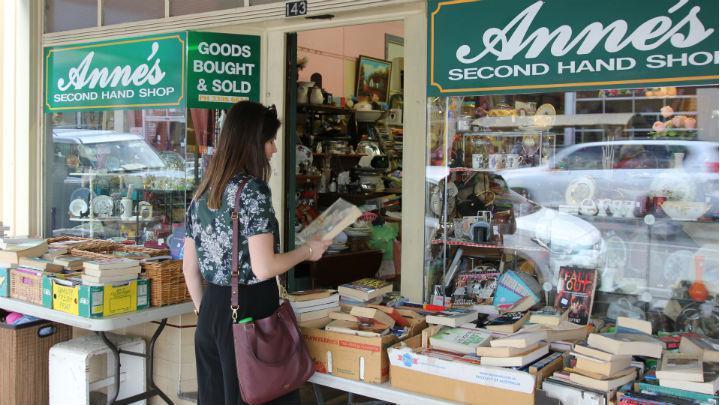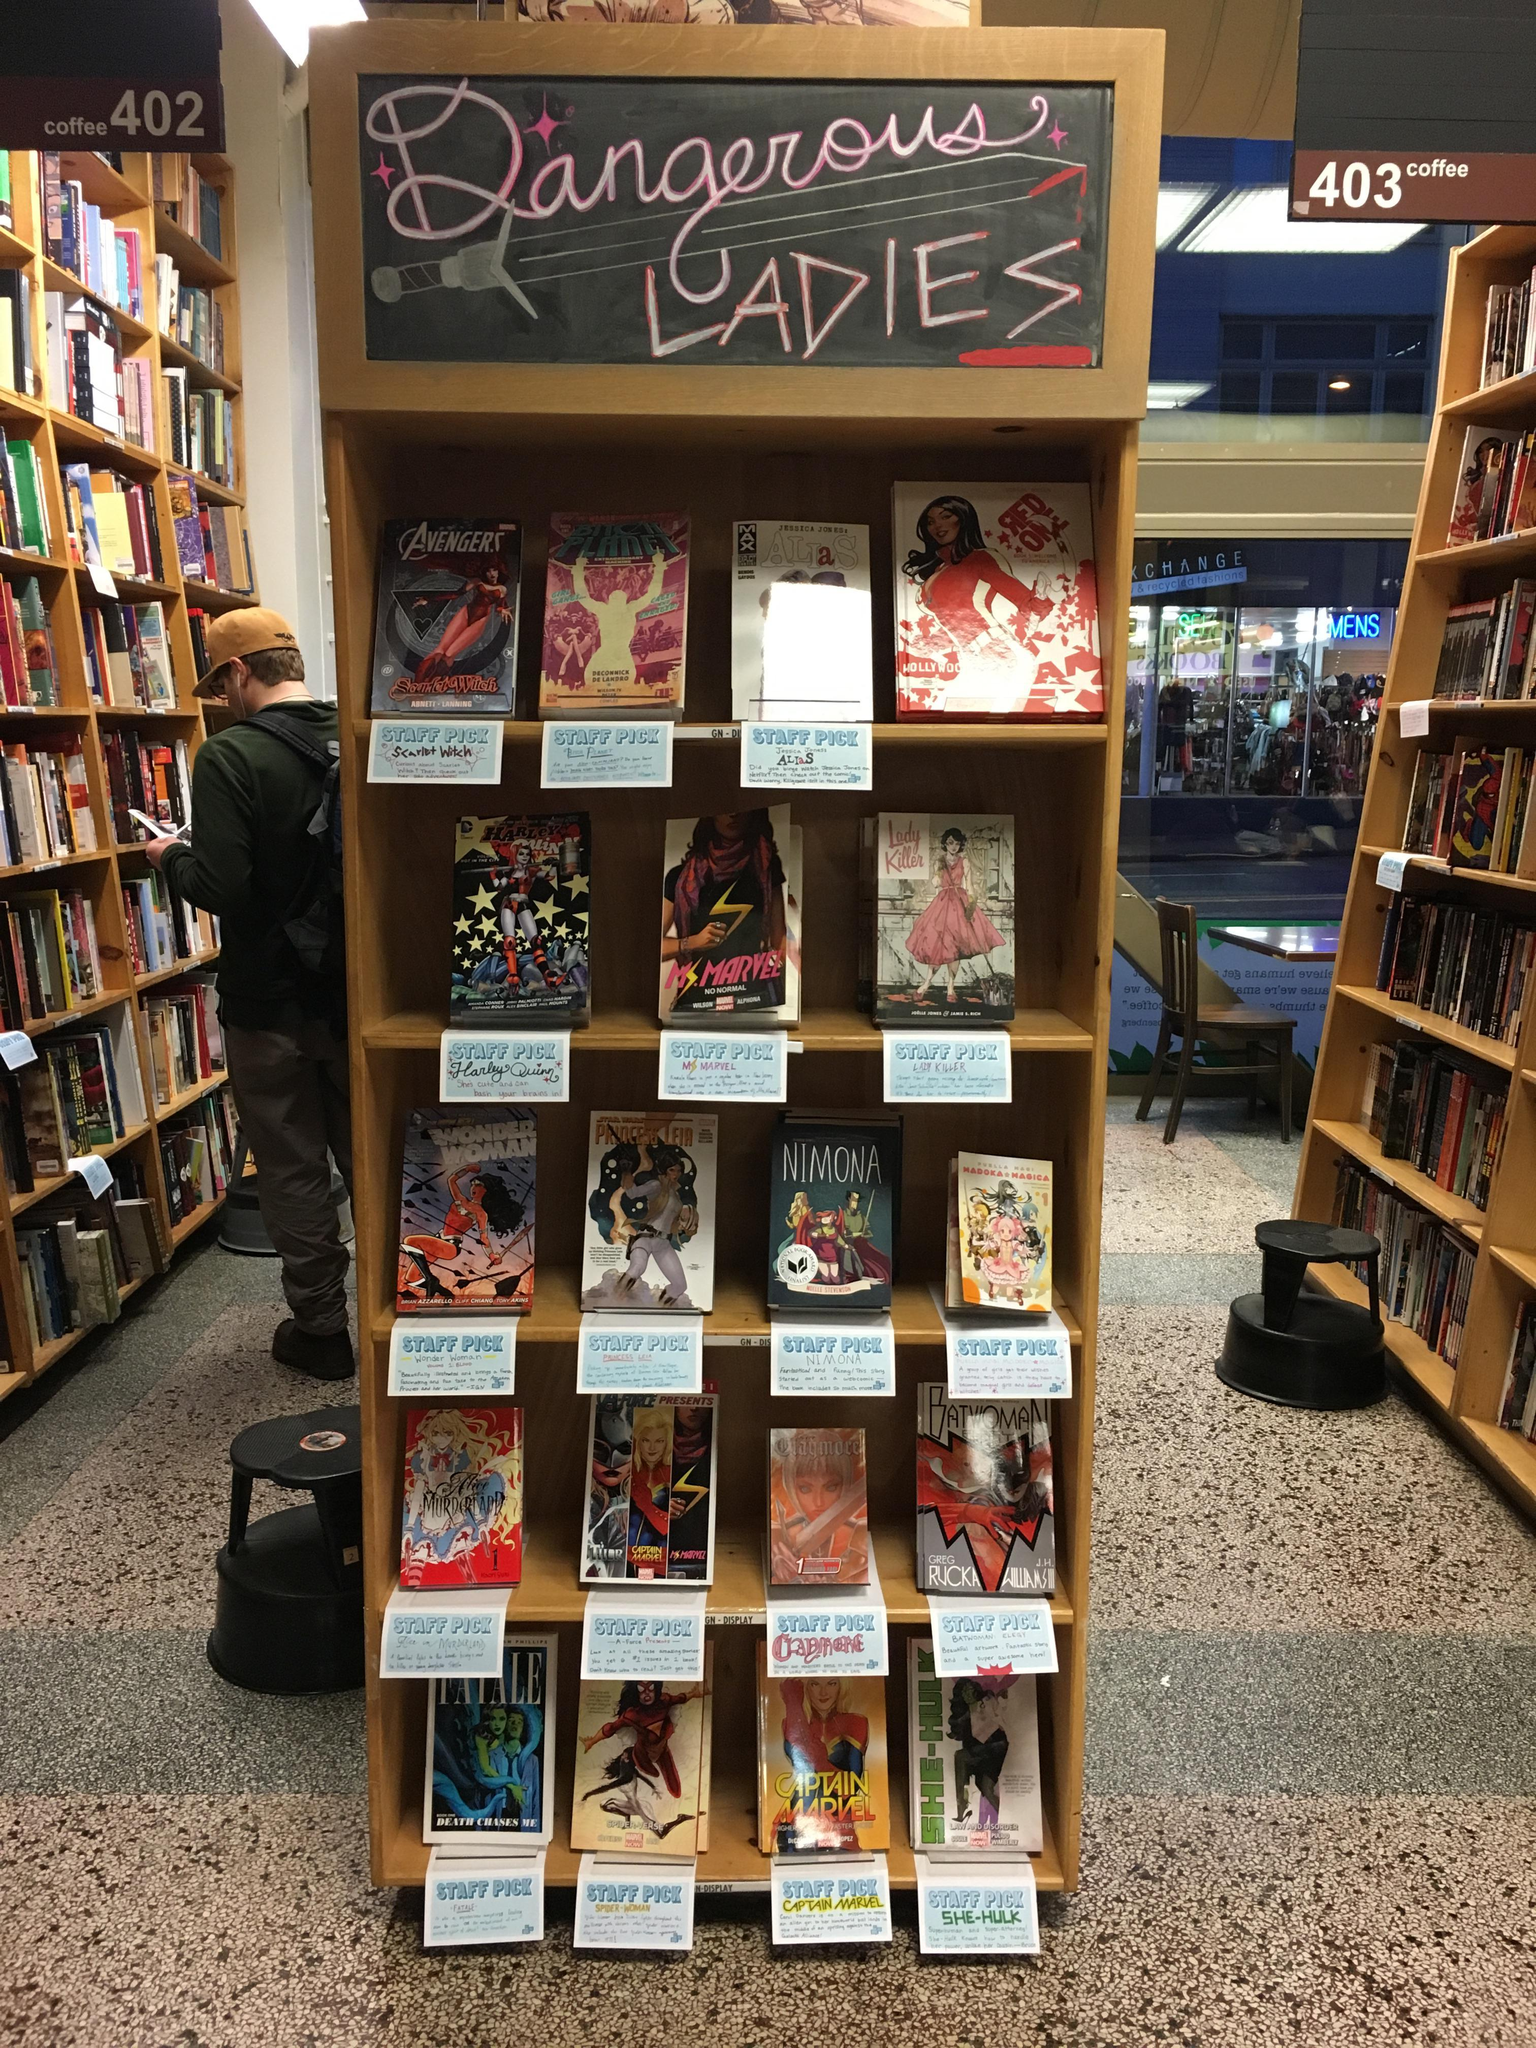The first image is the image on the left, the second image is the image on the right. For the images displayed, is the sentence "The left image shows the exterior of a shop with dark green signage and at least one table of items in front of one of the square glass windows flanking a single door." factually correct? Answer yes or no. Yes. The first image is the image on the left, the second image is the image on the right. For the images shown, is this caption "The people in the shop are standing up and browsing." true? Answer yes or no. Yes. 